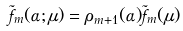<formula> <loc_0><loc_0><loc_500><loc_500>\tilde { f } _ { m } ( \alpha ; \mu ) = \rho _ { m + 1 } ( \alpha ) \tilde { f } _ { m } ( \mu )</formula> 